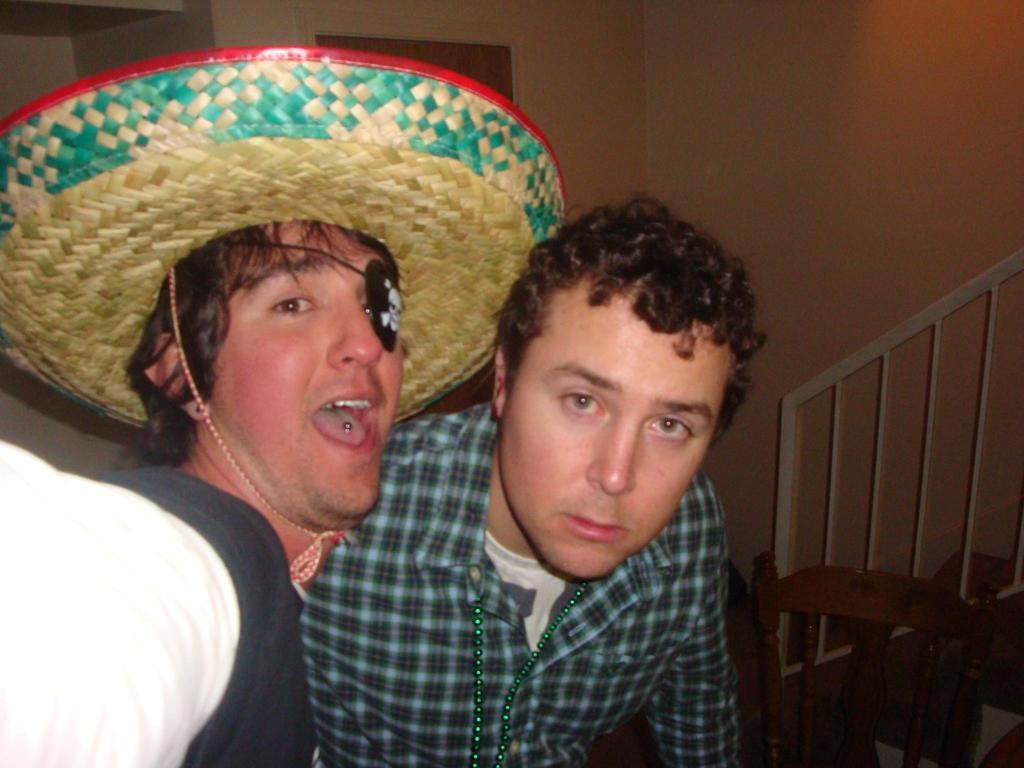How many people are in the image? There are 2 people in the image. What is the person on the left wearing on their head? The person on the left is wearing a hat and a pirate eye mask. What can be seen in the background of the image? There is a chair and stairs in the background of the image. Can you tell me how many monkeys are sitting on the roof in the image? There are no monkeys or roof present in the image. 